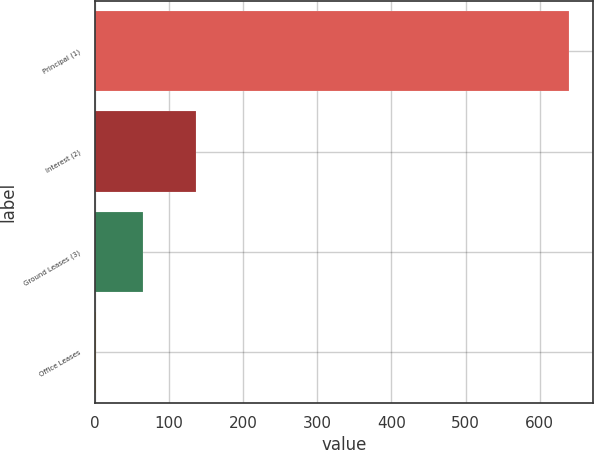Convert chart. <chart><loc_0><loc_0><loc_500><loc_500><bar_chart><fcel>Principal (1)<fcel>Interest (2)<fcel>Ground Leases (3)<fcel>Office Leases<nl><fcel>640.1<fcel>136.6<fcel>65.63<fcel>1.8<nl></chart> 